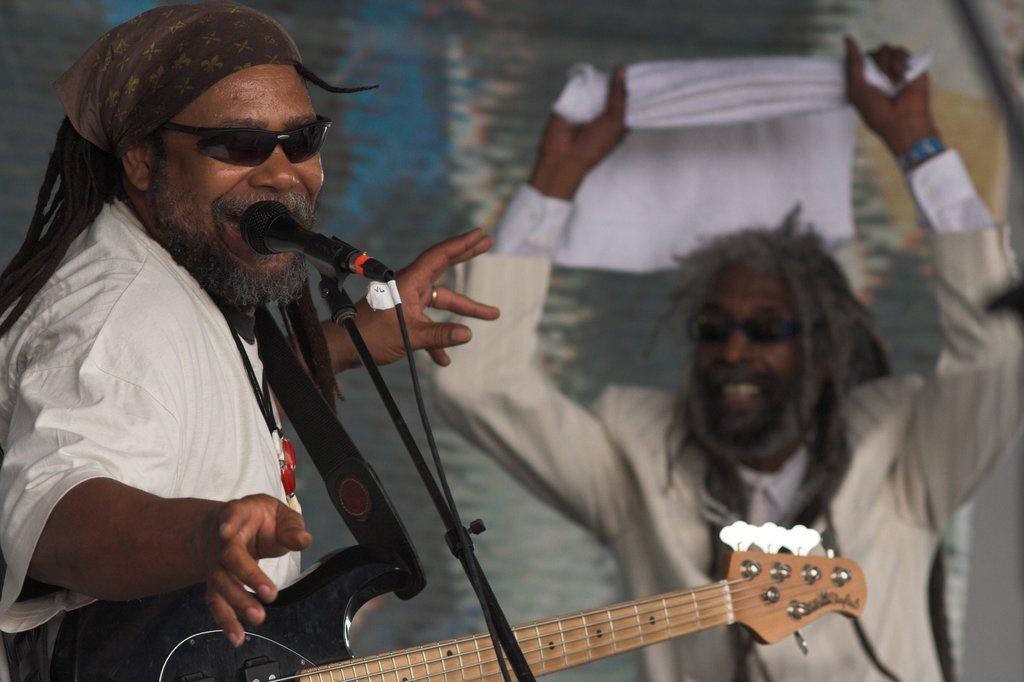Could you give a brief overview of what you see in this image? In this picture we can see two men, on the left side of the image we can see a man, he is carrying a guitar, in front of him we can find a microphone and we can see blurry background. 